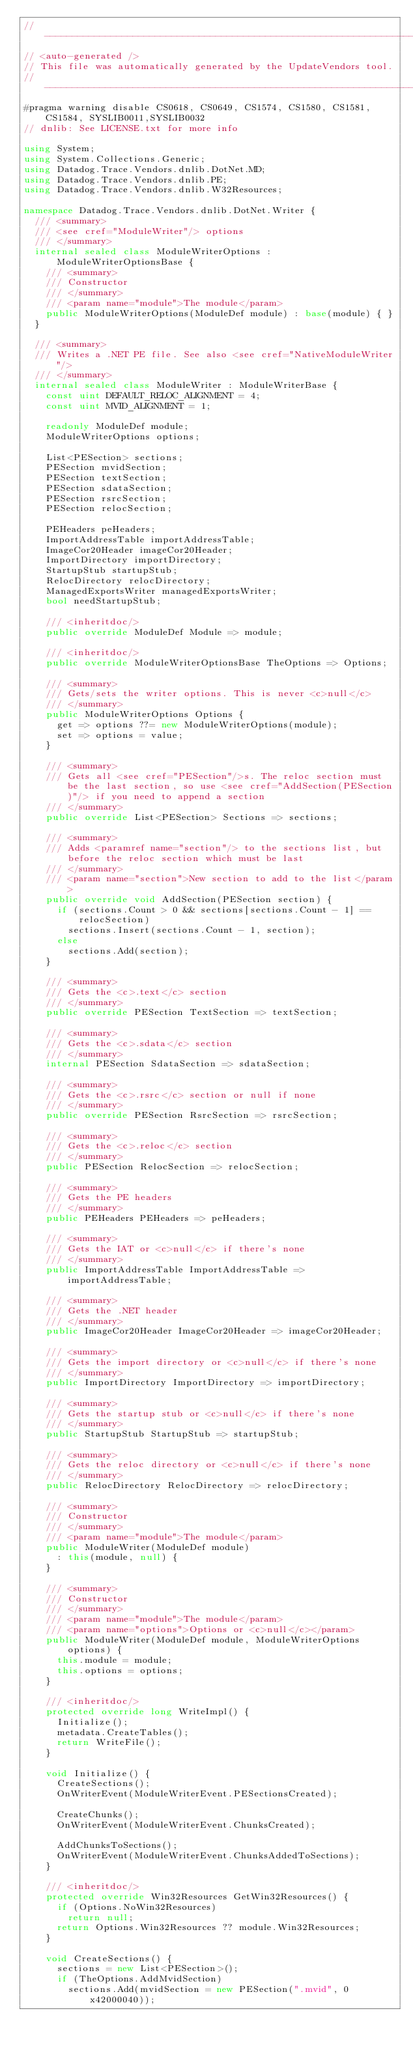Convert code to text. <code><loc_0><loc_0><loc_500><loc_500><_C#_>//------------------------------------------------------------------------------
// <auto-generated />
// This file was automatically generated by the UpdateVendors tool.
//------------------------------------------------------------------------------
#pragma warning disable CS0618, CS0649, CS1574, CS1580, CS1581, CS1584, SYSLIB0011,SYSLIB0032
// dnlib: See LICENSE.txt for more info

using System;
using System.Collections.Generic;
using Datadog.Trace.Vendors.dnlib.DotNet.MD;
using Datadog.Trace.Vendors.dnlib.PE;
using Datadog.Trace.Vendors.dnlib.W32Resources;

namespace Datadog.Trace.Vendors.dnlib.DotNet.Writer {
	/// <summary>
	/// <see cref="ModuleWriter"/> options
	/// </summary>
	internal sealed class ModuleWriterOptions : ModuleWriterOptionsBase {
		/// <summary>
		/// Constructor
		/// </summary>
		/// <param name="module">The module</param>
		public ModuleWriterOptions(ModuleDef module) : base(module) { }
	}

	/// <summary>
	/// Writes a .NET PE file. See also <see cref="NativeModuleWriter"/>
	/// </summary>
	internal sealed class ModuleWriter : ModuleWriterBase {
		const uint DEFAULT_RELOC_ALIGNMENT = 4;
		const uint MVID_ALIGNMENT = 1;

		readonly ModuleDef module;
		ModuleWriterOptions options;

		List<PESection> sections;
		PESection mvidSection;
		PESection textSection;
		PESection sdataSection;
		PESection rsrcSection;
		PESection relocSection;

		PEHeaders peHeaders;
		ImportAddressTable importAddressTable;
		ImageCor20Header imageCor20Header;
		ImportDirectory importDirectory;
		StartupStub startupStub;
		RelocDirectory relocDirectory;
		ManagedExportsWriter managedExportsWriter;
		bool needStartupStub;

		/// <inheritdoc/>
		public override ModuleDef Module => module;

		/// <inheritdoc/>
		public override ModuleWriterOptionsBase TheOptions => Options;

		/// <summary>
		/// Gets/sets the writer options. This is never <c>null</c>
		/// </summary>
		public ModuleWriterOptions Options {
			get => options ??= new ModuleWriterOptions(module);
			set => options = value;
		}

		/// <summary>
		/// Gets all <see cref="PESection"/>s. The reloc section must be the last section, so use <see cref="AddSection(PESection)"/> if you need to append a section
		/// </summary>
		public override List<PESection> Sections => sections;

		/// <summary>
		/// Adds <paramref name="section"/> to the sections list, but before the reloc section which must be last
		/// </summary>
		/// <param name="section">New section to add to the list</param>
		public override void AddSection(PESection section) {
			if (sections.Count > 0 && sections[sections.Count - 1] == relocSection)
				sections.Insert(sections.Count - 1, section);
			else
				sections.Add(section);
		}

		/// <summary>
		/// Gets the <c>.text</c> section
		/// </summary>
		public override PESection TextSection => textSection;

		/// <summary>
		/// Gets the <c>.sdata</c> section
		/// </summary>
		internal PESection SdataSection => sdataSection;

		/// <summary>
		/// Gets the <c>.rsrc</c> section or null if none
		/// </summary>
		public override PESection RsrcSection => rsrcSection;

		/// <summary>
		/// Gets the <c>.reloc</c> section
		/// </summary>
		public PESection RelocSection => relocSection;

		/// <summary>
		/// Gets the PE headers
		/// </summary>
		public PEHeaders PEHeaders => peHeaders;

		/// <summary>
		/// Gets the IAT or <c>null</c> if there's none
		/// </summary>
		public ImportAddressTable ImportAddressTable => importAddressTable;

		/// <summary>
		/// Gets the .NET header
		/// </summary>
		public ImageCor20Header ImageCor20Header => imageCor20Header;

		/// <summary>
		/// Gets the import directory or <c>null</c> if there's none
		/// </summary>
		public ImportDirectory ImportDirectory => importDirectory;

		/// <summary>
		/// Gets the startup stub or <c>null</c> if there's none
		/// </summary>
		public StartupStub StartupStub => startupStub;

		/// <summary>
		/// Gets the reloc directory or <c>null</c> if there's none
		/// </summary>
		public RelocDirectory RelocDirectory => relocDirectory;

		/// <summary>
		/// Constructor
		/// </summary>
		/// <param name="module">The module</param>
		public ModuleWriter(ModuleDef module)
			: this(module, null) {
		}

		/// <summary>
		/// Constructor
		/// </summary>
		/// <param name="module">The module</param>
		/// <param name="options">Options or <c>null</c></param>
		public ModuleWriter(ModuleDef module, ModuleWriterOptions options) {
			this.module = module;
			this.options = options;
		}

		/// <inheritdoc/>
		protected override long WriteImpl() {
			Initialize();
			metadata.CreateTables();
			return WriteFile();
		}

		void Initialize() {
			CreateSections();
			OnWriterEvent(ModuleWriterEvent.PESectionsCreated);

			CreateChunks();
			OnWriterEvent(ModuleWriterEvent.ChunksCreated);

			AddChunksToSections();
			OnWriterEvent(ModuleWriterEvent.ChunksAddedToSections);
		}

		/// <inheritdoc/>
		protected override Win32Resources GetWin32Resources() {
			if (Options.NoWin32Resources)
				return null;
			return Options.Win32Resources ?? module.Win32Resources;
		}

		void CreateSections() {
			sections = new List<PESection>();
			if (TheOptions.AddMvidSection)
				sections.Add(mvidSection = new PESection(".mvid", 0x42000040));</code> 